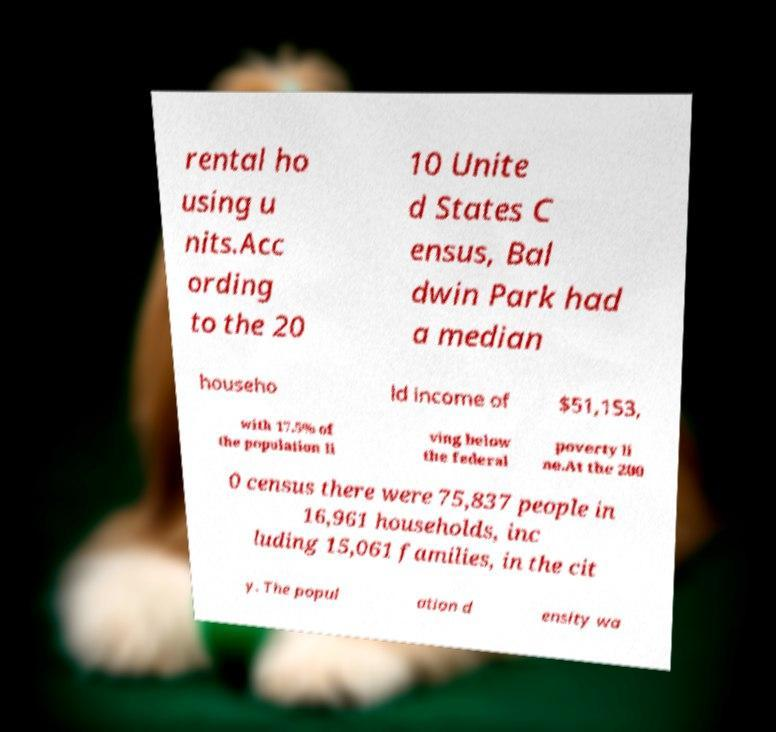What messages or text are displayed in this image? I need them in a readable, typed format. rental ho using u nits.Acc ording to the 20 10 Unite d States C ensus, Bal dwin Park had a median househo ld income of $51,153, with 17.5% of the population li ving below the federal poverty li ne.At the 200 0 census there were 75,837 people in 16,961 households, inc luding 15,061 families, in the cit y. The popul ation d ensity wa 